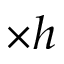<formula> <loc_0><loc_0><loc_500><loc_500>\times h</formula> 